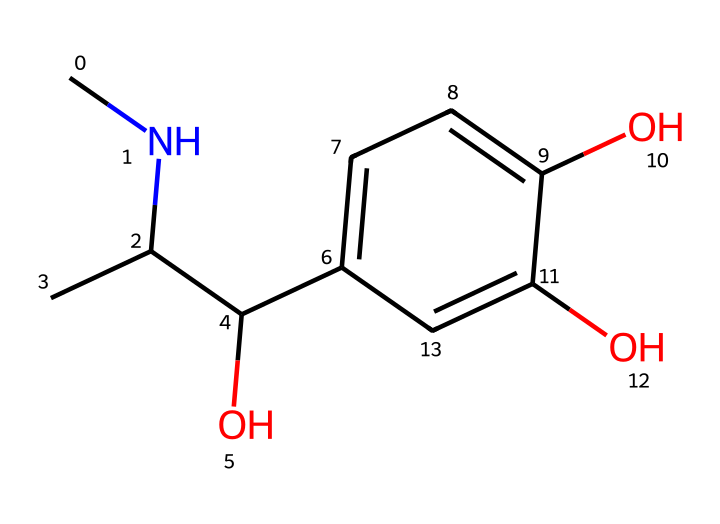What is the molecular formula of this chemical? To determine the molecular formula from the SMILES representation, I will count the number of each type of atom represented. In the provided SMILES, there are 9 carbon atoms, 13 hydrogen atoms, and 3 oxygen atoms. Therefore, the molecular formula is C9H13O3.
Answer: C9H13O3 How many hydroxyl (-OH) groups are present in this chemical? By examining the structure indicated by the SMILES, I note that there are three occurrences of the oxygen atom connected to hydrogen (hydroxyl groups). Each of these represents a hydroxyl group, so the total is three.
Answer: 3 Is this chemical likely to be polar or nonpolar? Given that the structure contains multiple hydroxyl groups, which are polar, and the presence of several electronegative oxygen atoms, this chemical is likely to be polar overall due to the high density of polar functional groups.
Answer: polar What type of hormone is this chemical classified as? The chemical structure aligns with common characteristics found in hormones, specifically because it is synthesized in the body and triggers physiological responses like the "fight or flight" response. Thus, it is classified as a hormone.
Answer: hormone What functional groups are present in this chemical? By analyzing the SMILES representation, I identify the presence of hydroxyl (-OH) groups and an amine (-NH) group, which are typical functional groups associated with this type of chemical. Therefore, the identified functional groups are hydroxyl groups and an amine.
Answer: hydroxyl and amine Which atoms are present in the largest quantity in this chemical? From the molecular formula determined, there are 9 carbon atoms, which outnumber the other elements. By comparison with hydrogen and oxygen, the carbon atoms are present in the largest quantity.
Answer: carbon 